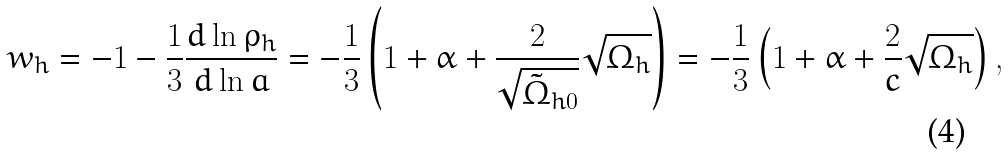Convert formula to latex. <formula><loc_0><loc_0><loc_500><loc_500>w _ { h } = - 1 - \frac { 1 } { 3 } \frac { d \ln \rho _ { h } } { d \ln a } = - \frac { 1 } { 3 } \left ( 1 + \alpha + \frac { 2 } { \sqrt { \tilde { \Omega } _ { h 0 } } } \sqrt { \Omega _ { h } } \right ) = - \frac { 1 } { 3 } \left ( 1 + \alpha + \frac { 2 } { c } \sqrt { \Omega _ { h } } \right ) ,</formula> 